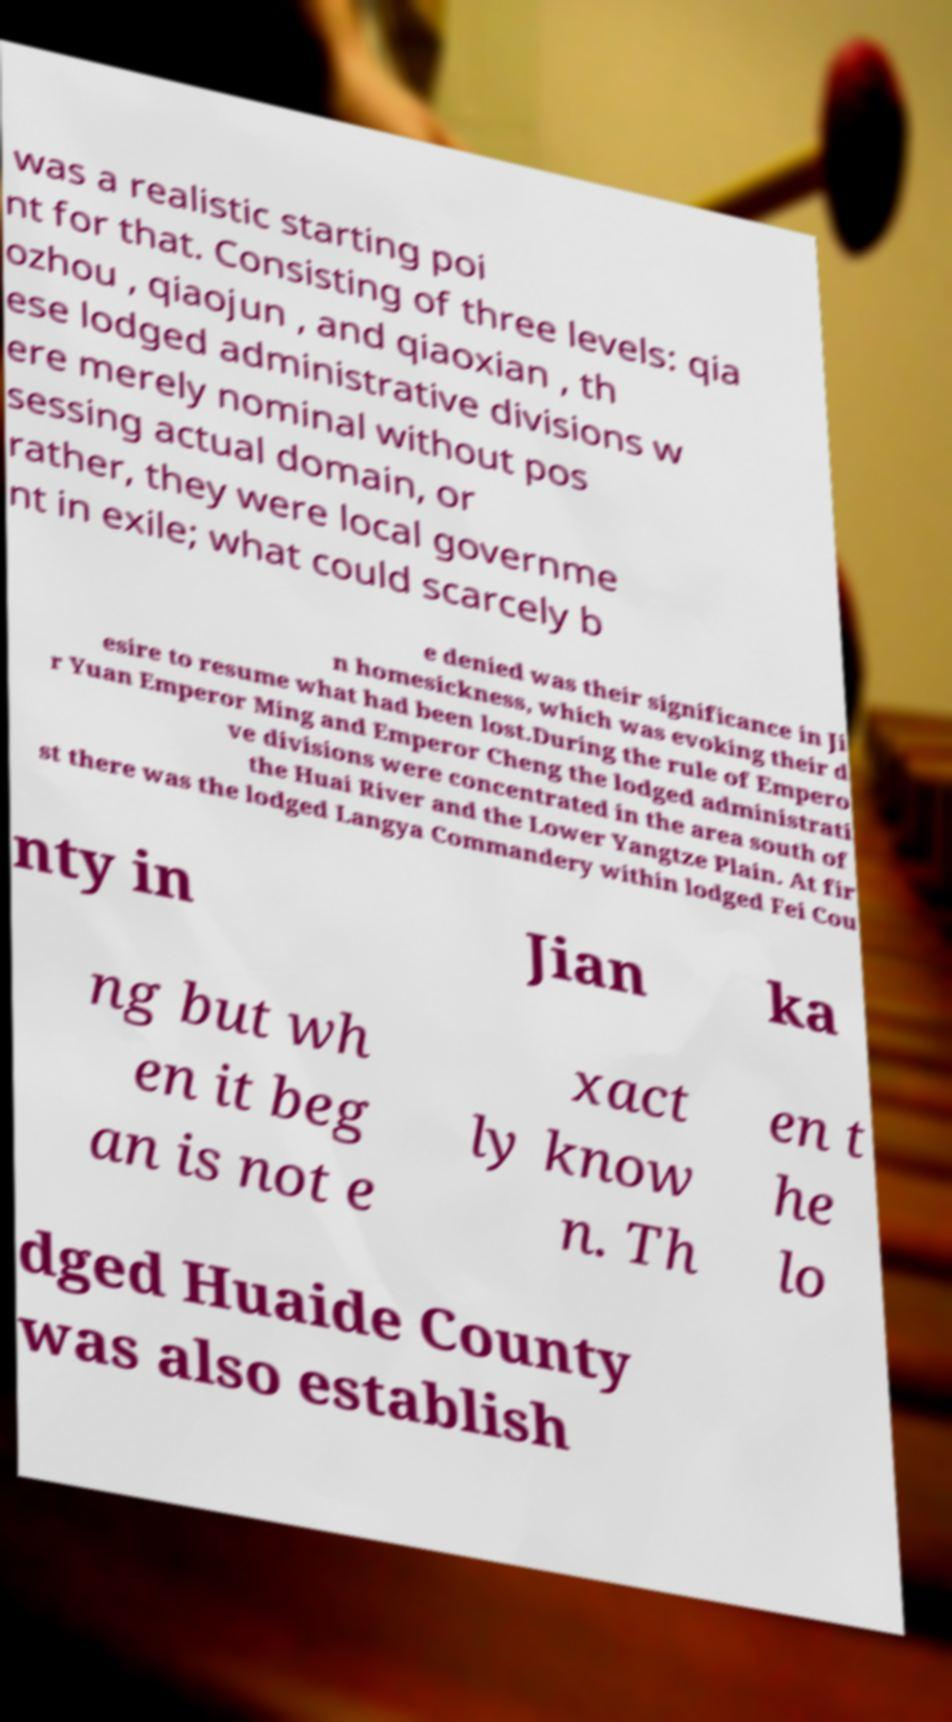Can you read and provide the text displayed in the image?This photo seems to have some interesting text. Can you extract and type it out for me? was a realistic starting poi nt for that. Consisting of three levels: qia ozhou , qiaojun , and qiaoxian , th ese lodged administrative divisions w ere merely nominal without pos sessing actual domain, or rather, they were local governme nt in exile; what could scarcely b e denied was their significance in Ji n homesickness, which was evoking their d esire to resume what had been lost.During the rule of Empero r Yuan Emperor Ming and Emperor Cheng the lodged administrati ve divisions were concentrated in the area south of the Huai River and the Lower Yangtze Plain. At fir st there was the lodged Langya Commandery within lodged Fei Cou nty in Jian ka ng but wh en it beg an is not e xact ly know n. Th en t he lo dged Huaide County was also establish 